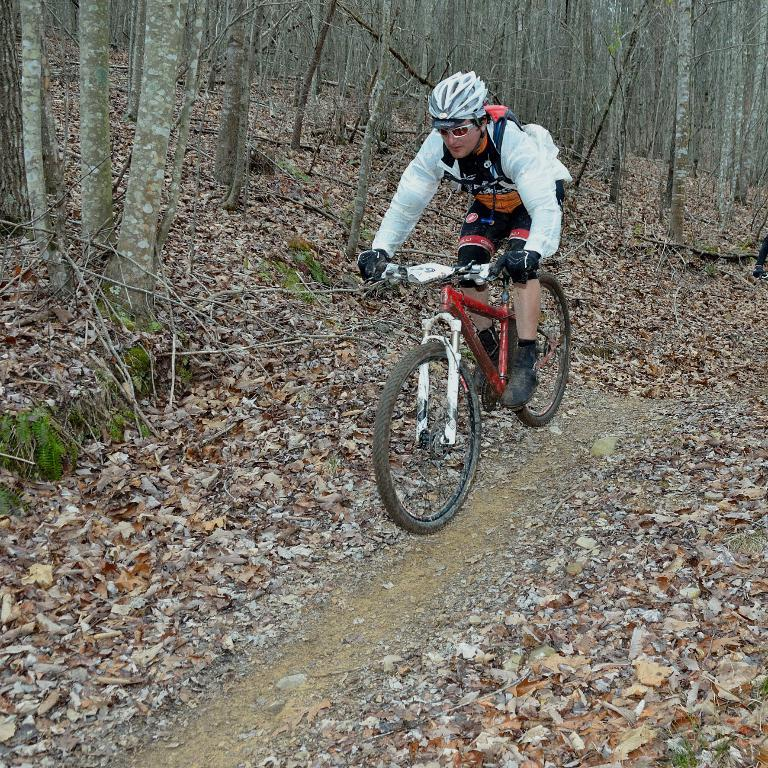Who or what is the main subject in the image? There is a person in the image. What is the person wearing? The person is wearing a helmet. What is the person doing in the image? The person is sitting on a bicycle. What can be seen on the ground in the image? There are dry leaves on the ground. What is visible in the background of the image? Tree trunks are visible in the background. What type of flower can be seen growing near the tree trunks in the image? There are no flowers visible in the image; only dry leaves on the ground and tree trunks in the background. 